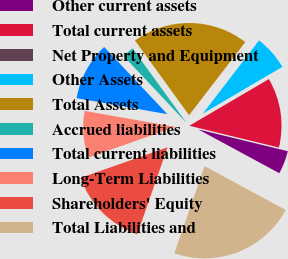<chart> <loc_0><loc_0><loc_500><loc_500><pie_chart><fcel>Other current assets<fcel>Total current assets<fcel>Net Property and Equipment<fcel>Other Assets<fcel>Total Assets<fcel>Accrued liabilities<fcel>Total current liabilities<fcel>Long-Term Liabilities<fcel>Shareholders' Equity<fcel>Total Liabilities and<nl><fcel>4.08%<fcel>12.24%<fcel>0.0%<fcel>6.12%<fcel>20.4%<fcel>2.04%<fcel>10.2%<fcel>8.16%<fcel>14.28%<fcel>22.44%<nl></chart> 